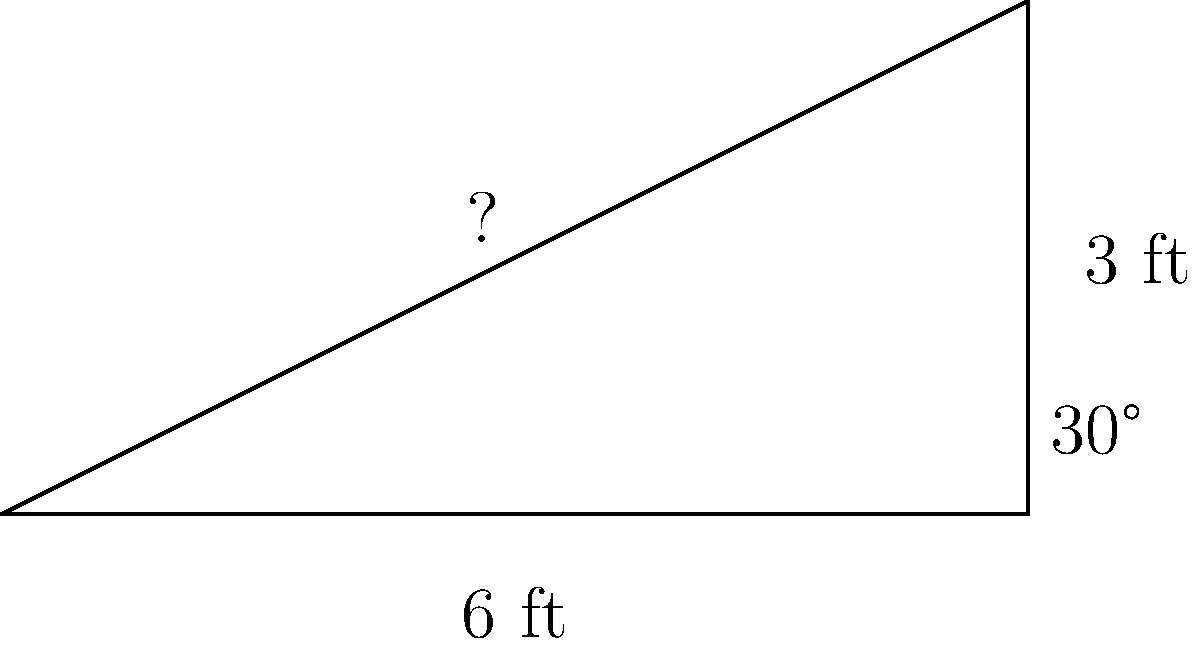At your church's Easter service, the gospel choir needs to stand on a riser. The riser's base is 6 feet wide, and you notice that the angle between the base and the sloped side is 30°. If the choir director wants the back row to be 3 feet higher than the front, what is the length of the sloped side of the riser? Let's approach this step-by-step using trigonometry:

1) We have a right triangle where:
   - The base (adjacent side) is 6 feet
   - The height (opposite side) is 3 feet
   - The angle at the base is 30°
   - We need to find the hypotenuse (sloped side)

2) We can use the tangent ratio to verify the angle:
   $\tan 30° = \frac{\text{opposite}}{\text{adjacent}} = \frac{3}{6} = 0.5$
   This confirms that the angle is indeed 30°

3) To find the hypotenuse, we can use the Pythagorean theorem:
   $a^2 + b^2 = c^2$
   Where $a$ is the adjacent side (6 ft), $b$ is the opposite side (3 ft), and $c$ is the hypotenuse

4) Plugging in the values:
   $6^2 + 3^2 = c^2$
   $36 + 9 = c^2$
   $45 = c^2$

5) Taking the square root of both sides:
   $\sqrt{45} = c$
   $3\sqrt{5} \approx 6.71$ feet

Therefore, the length of the sloped side of the riser is $3\sqrt{5}$ feet or approximately 6.71 feet.
Answer: $3\sqrt{5}$ feet 